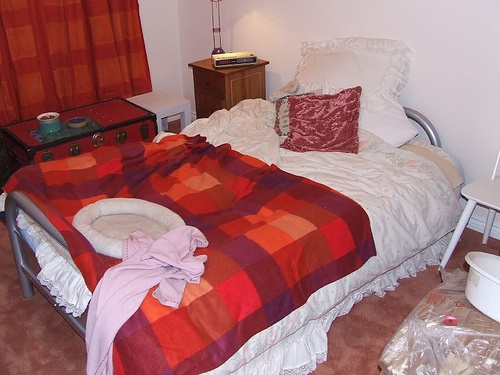Describe the objects in this image and their specific colors. I can see bed in maroon, brown, and darkgray tones, chair in maroon, darkgray, lightgray, and gray tones, vase in maroon, darkgray, gray, brown, and lightpink tones, clock in maroon, black, gray, and purple tones, and bowl in maroon, black, and brown tones in this image. 